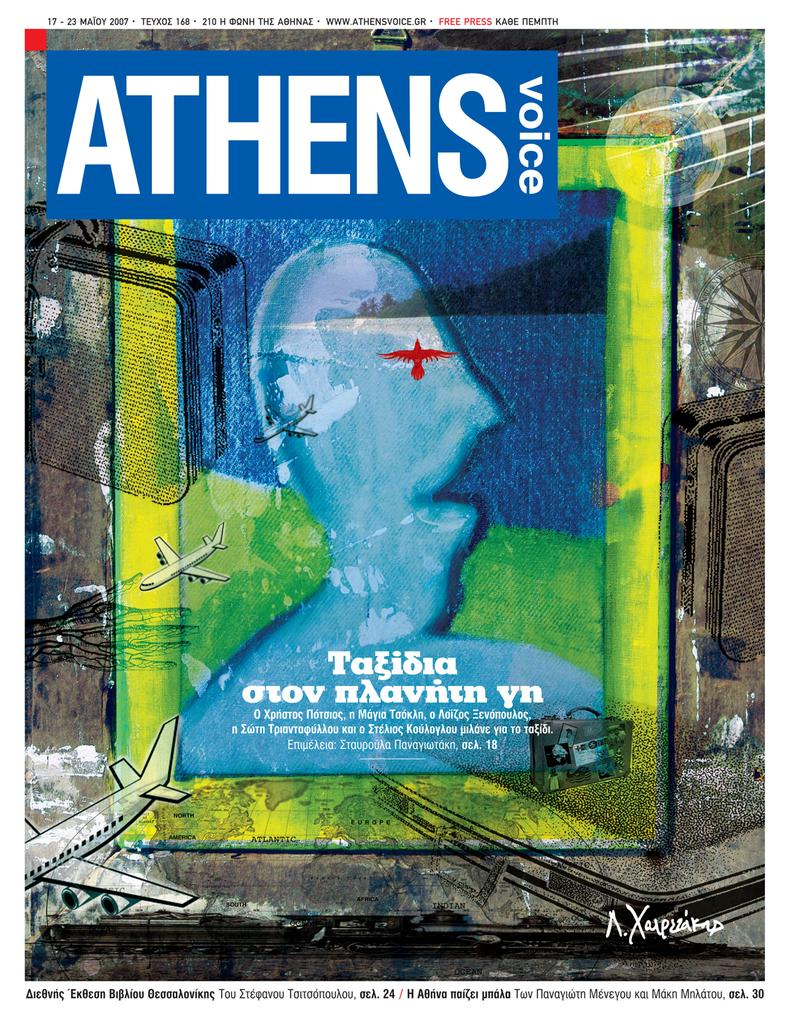Provide a one-sentence caption for the provided image. A digital print of the Athens Voice magazine cover from 2007. 